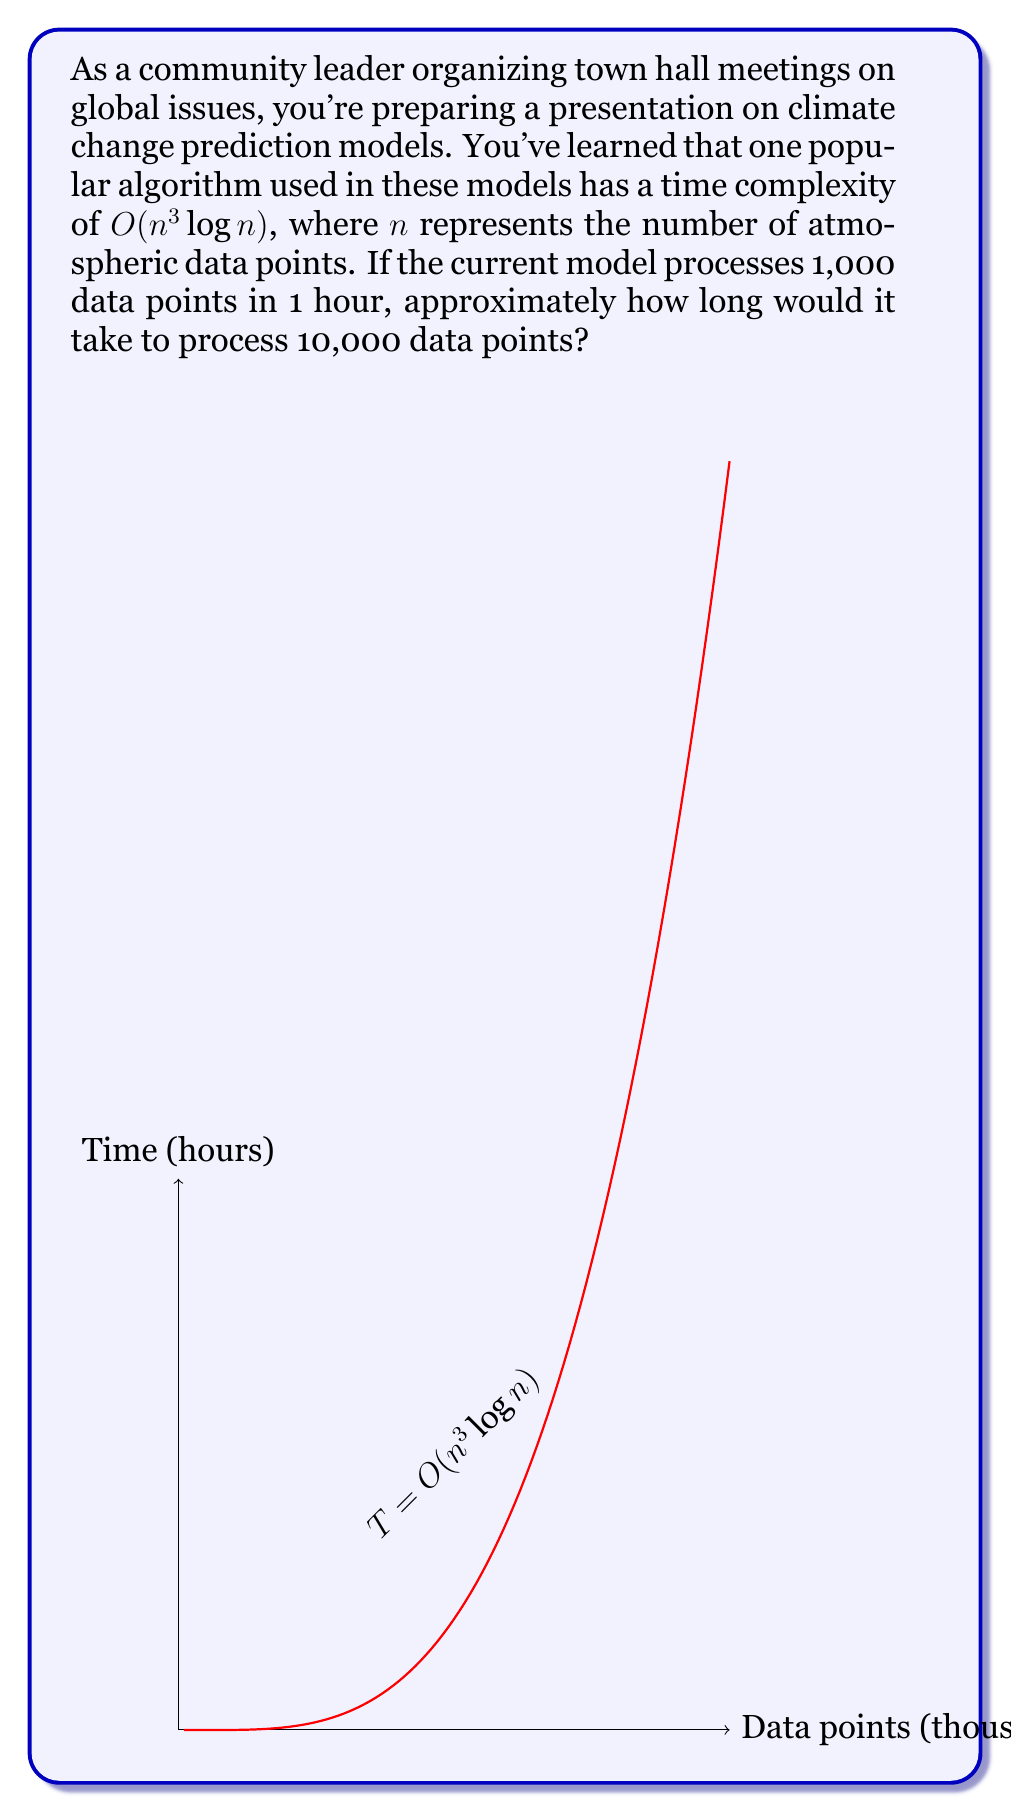Teach me how to tackle this problem. Let's approach this step-by-step:

1) The time complexity is $O(n^3 \log n)$. This means the running time is proportional to $n^3 \log n$.

2) Let's call the proportionality constant $k$. So, the running time $T$ can be expressed as:
   $T = k \cdot n^3 \log n$

3) For the current model:
   $1 \text{ hour} = k \cdot 1000^3 \log 1000$

4) Solve for $k$:
   $k = \frac{1}{1000^3 \log 1000} \approx 1.085 \times 10^{-10}$

5) Now, for 10,000 data points:
   $T = k \cdot 10000^3 \log 10000$

6) Substitute the value of $k$:
   $T = 1.085 \times 10^{-10} \cdot 10000^3 \log 10000$

7) Calculate:
   $T \approx 1000 \text{ hours}$

8) Convert to days:
   $1000 \text{ hours} \approx 41.67 \text{ days}$

Therefore, it would take approximately 1000 hours or about 42 days to process 10,000 data points.
Answer: Approximately 1000 hours or 42 days 